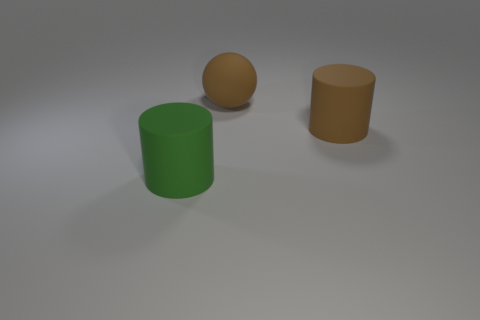Is the number of brown cylinders on the right side of the rubber sphere greater than the number of cylinders that are in front of the big brown rubber cylinder?
Provide a short and direct response. No. What is the material of the green thing that is the same size as the brown sphere?
Your answer should be very brief. Rubber. How many small things are brown cylinders or gray metallic cylinders?
Your answer should be very brief. 0. What number of large rubber things are on the left side of the big brown rubber cylinder and on the right side of the green cylinder?
Your response must be concise. 1. Is there anything else of the same color as the big matte sphere?
Your response must be concise. Yes. What shape is the brown object that is made of the same material as the brown sphere?
Offer a very short reply. Cylinder. Do the ball and the green object have the same size?
Provide a succinct answer. Yes. Is the material of the cylinder that is behind the large green rubber cylinder the same as the brown sphere?
Offer a terse response. Yes. Is there anything else that is the same material as the big green object?
Provide a succinct answer. Yes. What number of rubber objects are left of the large thing that is behind the large brown object that is right of the brown ball?
Provide a succinct answer. 1. 